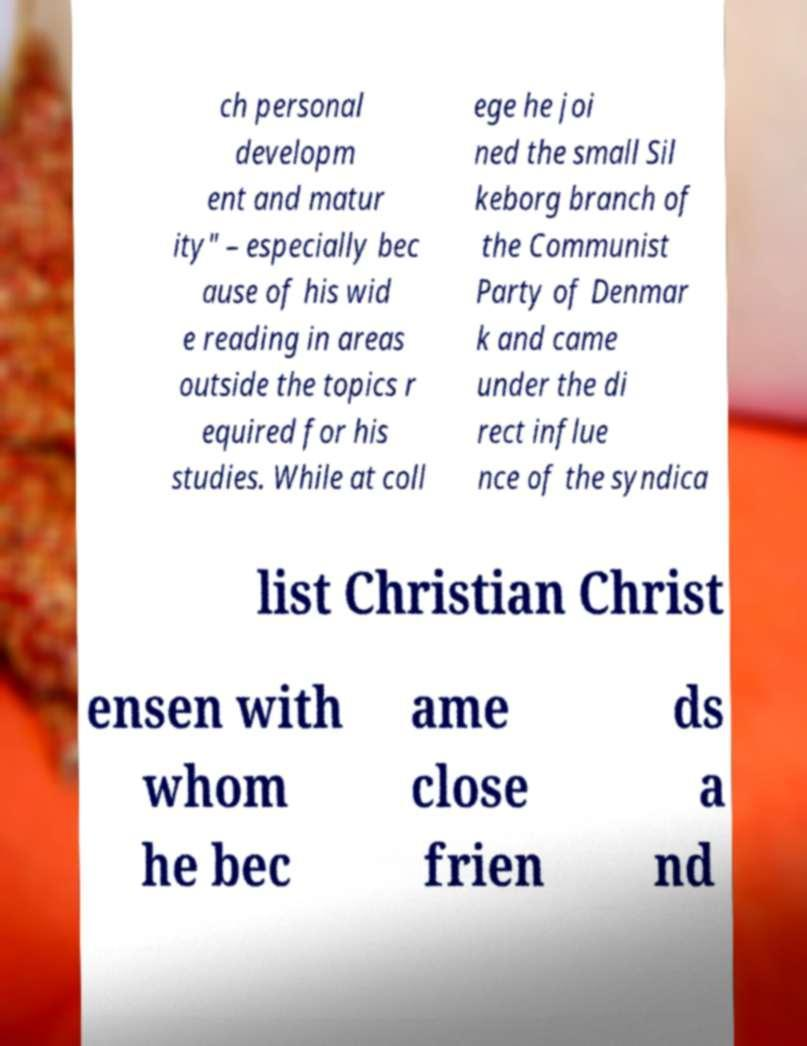Please identify and transcribe the text found in this image. ch personal developm ent and matur ity" – especially bec ause of his wid e reading in areas outside the topics r equired for his studies. While at coll ege he joi ned the small Sil keborg branch of the Communist Party of Denmar k and came under the di rect influe nce of the syndica list Christian Christ ensen with whom he bec ame close frien ds a nd 